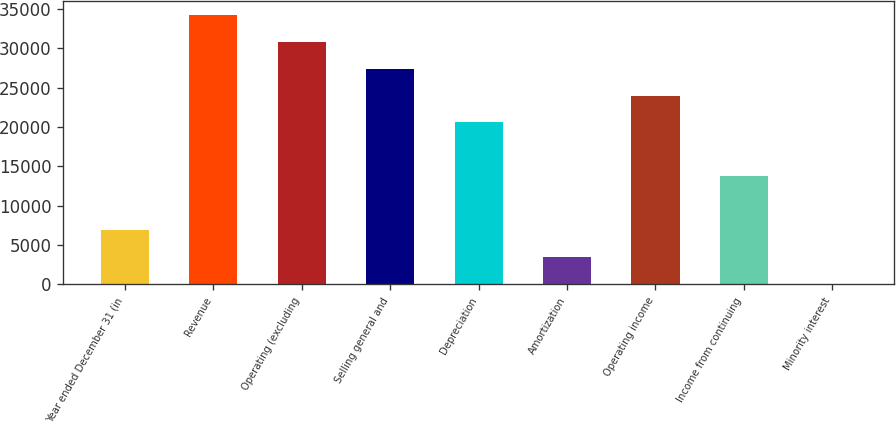<chart> <loc_0><loc_0><loc_500><loc_500><bar_chart><fcel>Year ended December 31 (in<fcel>Revenue<fcel>Operating (excluding<fcel>Selling general and<fcel>Depreciation<fcel>Amortization<fcel>Operating income<fcel>Income from continuing<fcel>Minority interest<nl><fcel>6868.8<fcel>34256<fcel>30832.6<fcel>27409.2<fcel>20562.4<fcel>3445.4<fcel>23985.8<fcel>13715.6<fcel>22<nl></chart> 